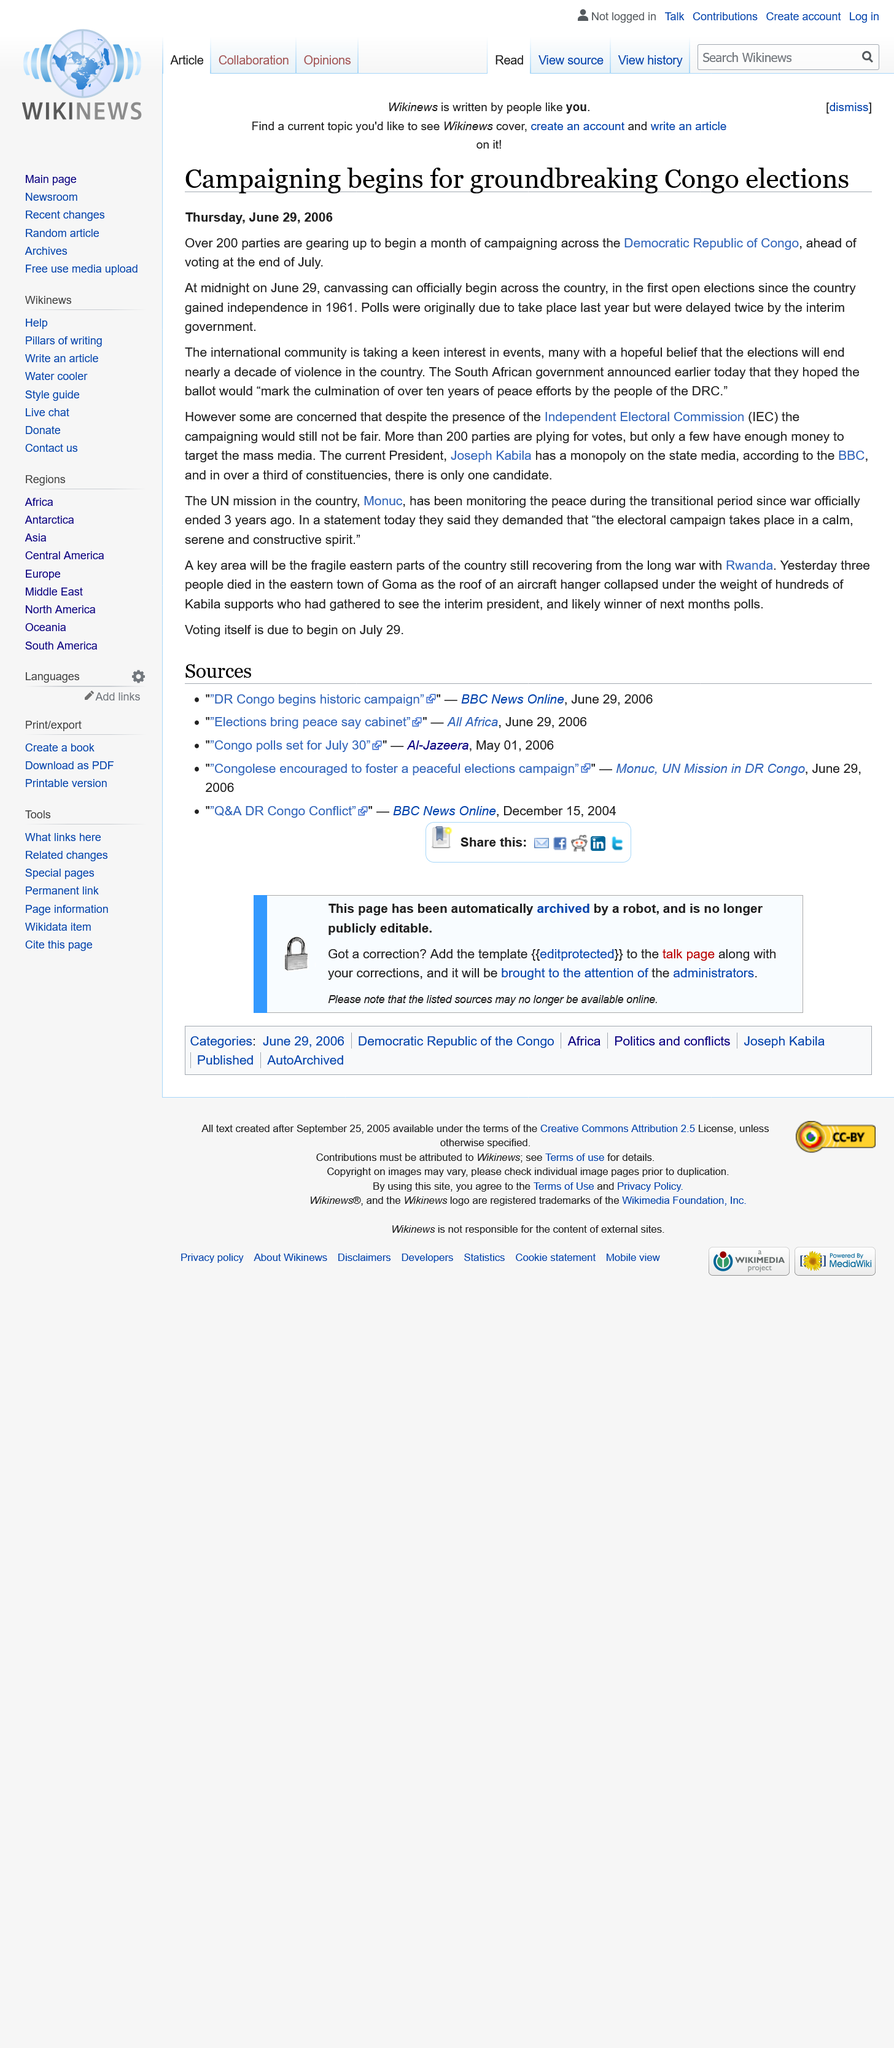Mention a couple of crucial points in this snapshot. Congo gained its independence on 30 June 1961, ending over 70 years of Belgian colonial rule. On June 29, 2006, canvassing officially began. There are over 200 political parties currently campaigning across the Democratic Republic of the Congo. 